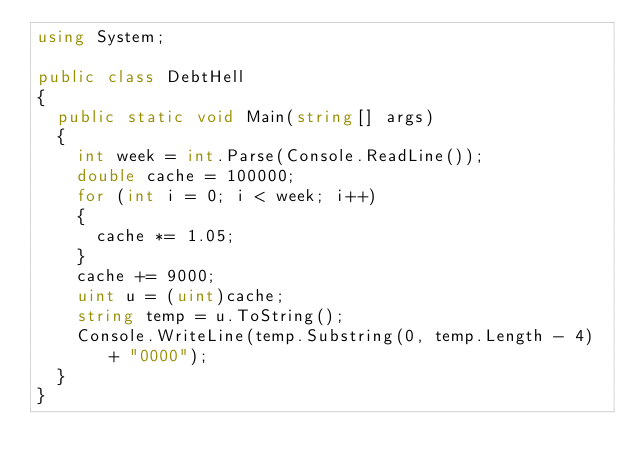<code> <loc_0><loc_0><loc_500><loc_500><_C#_>using System;

public class DebtHell
{
	public static void Main(string[] args)
	{
		int week = int.Parse(Console.ReadLine());
		double cache = 100000;
		for (int i = 0; i < week; i++)
		{
			cache *= 1.05;
		}
		cache += 9000;
		uint u = (uint)cache;
		string temp = u.ToString();
		Console.WriteLine(temp.Substring(0, temp.Length - 4) + "0000");
	}
}</code> 